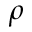Convert formula to latex. <formula><loc_0><loc_0><loc_500><loc_500>\rho</formula> 